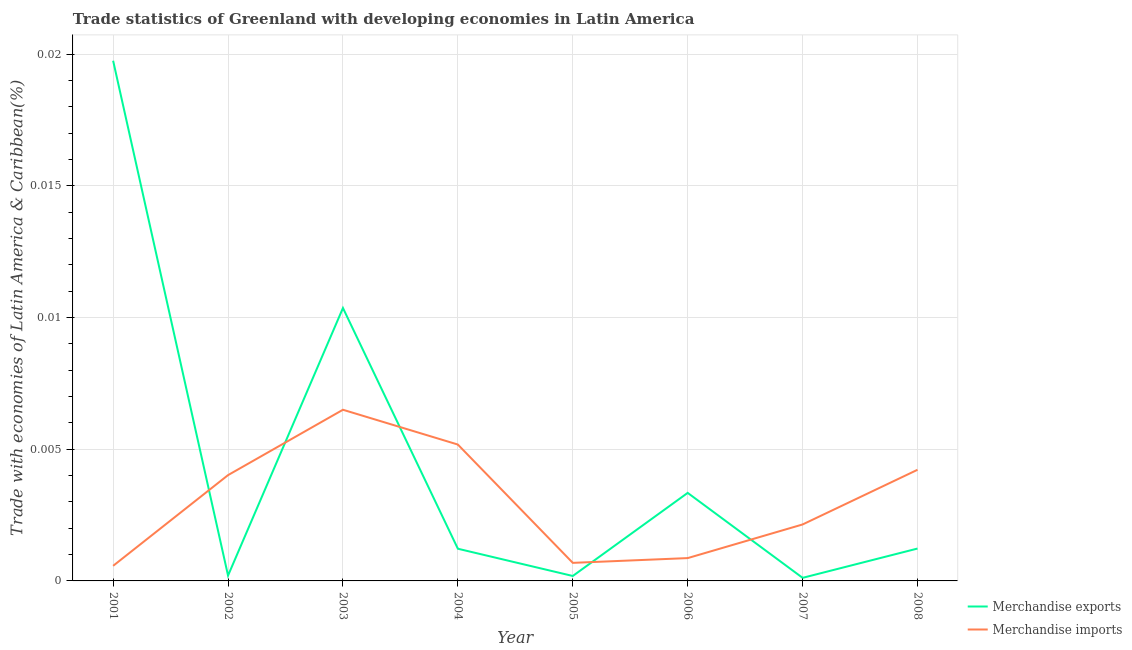How many different coloured lines are there?
Offer a terse response. 2. Is the number of lines equal to the number of legend labels?
Provide a short and direct response. Yes. What is the merchandise exports in 2006?
Provide a succinct answer. 0. Across all years, what is the maximum merchandise imports?
Provide a succinct answer. 0.01. Across all years, what is the minimum merchandise imports?
Offer a very short reply. 0. In which year was the merchandise exports maximum?
Your response must be concise. 2001. What is the total merchandise imports in the graph?
Give a very brief answer. 0.02. What is the difference between the merchandise exports in 2001 and that in 2006?
Offer a very short reply. 0.02. What is the difference between the merchandise exports in 2007 and the merchandise imports in 2006?
Ensure brevity in your answer.  -0. What is the average merchandise exports per year?
Your response must be concise. 0. In the year 2007, what is the difference between the merchandise exports and merchandise imports?
Offer a very short reply. -0. In how many years, is the merchandise exports greater than 0.006 %?
Your answer should be very brief. 2. What is the ratio of the merchandise exports in 2001 to that in 2003?
Ensure brevity in your answer.  1.91. Is the merchandise imports in 2002 less than that in 2005?
Make the answer very short. No. Is the difference between the merchandise exports in 2004 and 2007 greater than the difference between the merchandise imports in 2004 and 2007?
Offer a very short reply. No. What is the difference between the highest and the second highest merchandise imports?
Your answer should be very brief. 0. What is the difference between the highest and the lowest merchandise imports?
Make the answer very short. 0.01. Does the merchandise exports monotonically increase over the years?
Your answer should be very brief. No. Is the merchandise imports strictly greater than the merchandise exports over the years?
Ensure brevity in your answer.  No. How many lines are there?
Your answer should be very brief. 2. What is the difference between two consecutive major ticks on the Y-axis?
Provide a succinct answer. 0.01. Does the graph contain any zero values?
Offer a very short reply. No. Does the graph contain grids?
Your response must be concise. Yes. How many legend labels are there?
Your answer should be very brief. 2. How are the legend labels stacked?
Offer a very short reply. Vertical. What is the title of the graph?
Offer a terse response. Trade statistics of Greenland with developing economies in Latin America. Does "Education" appear as one of the legend labels in the graph?
Provide a short and direct response. No. What is the label or title of the X-axis?
Give a very brief answer. Year. What is the label or title of the Y-axis?
Your answer should be compact. Trade with economies of Latin America & Caribbean(%). What is the Trade with economies of Latin America & Caribbean(%) in Merchandise exports in 2001?
Provide a succinct answer. 0.02. What is the Trade with economies of Latin America & Caribbean(%) in Merchandise imports in 2001?
Keep it short and to the point. 0. What is the Trade with economies of Latin America & Caribbean(%) in Merchandise exports in 2002?
Your answer should be very brief. 0. What is the Trade with economies of Latin America & Caribbean(%) of Merchandise imports in 2002?
Keep it short and to the point. 0. What is the Trade with economies of Latin America & Caribbean(%) of Merchandise exports in 2003?
Your answer should be compact. 0.01. What is the Trade with economies of Latin America & Caribbean(%) in Merchandise imports in 2003?
Provide a succinct answer. 0.01. What is the Trade with economies of Latin America & Caribbean(%) of Merchandise exports in 2004?
Provide a succinct answer. 0. What is the Trade with economies of Latin America & Caribbean(%) in Merchandise imports in 2004?
Keep it short and to the point. 0.01. What is the Trade with economies of Latin America & Caribbean(%) in Merchandise exports in 2005?
Ensure brevity in your answer.  0. What is the Trade with economies of Latin America & Caribbean(%) in Merchandise imports in 2005?
Provide a short and direct response. 0. What is the Trade with economies of Latin America & Caribbean(%) in Merchandise exports in 2006?
Make the answer very short. 0. What is the Trade with economies of Latin America & Caribbean(%) of Merchandise imports in 2006?
Ensure brevity in your answer.  0. What is the Trade with economies of Latin America & Caribbean(%) of Merchandise exports in 2007?
Give a very brief answer. 0. What is the Trade with economies of Latin America & Caribbean(%) in Merchandise imports in 2007?
Keep it short and to the point. 0. What is the Trade with economies of Latin America & Caribbean(%) in Merchandise exports in 2008?
Offer a very short reply. 0. What is the Trade with economies of Latin America & Caribbean(%) in Merchandise imports in 2008?
Keep it short and to the point. 0. Across all years, what is the maximum Trade with economies of Latin America & Caribbean(%) in Merchandise exports?
Ensure brevity in your answer.  0.02. Across all years, what is the maximum Trade with economies of Latin America & Caribbean(%) in Merchandise imports?
Keep it short and to the point. 0.01. Across all years, what is the minimum Trade with economies of Latin America & Caribbean(%) in Merchandise exports?
Ensure brevity in your answer.  0. Across all years, what is the minimum Trade with economies of Latin America & Caribbean(%) in Merchandise imports?
Provide a succinct answer. 0. What is the total Trade with economies of Latin America & Caribbean(%) in Merchandise exports in the graph?
Your answer should be compact. 0.04. What is the total Trade with economies of Latin America & Caribbean(%) in Merchandise imports in the graph?
Provide a short and direct response. 0.02. What is the difference between the Trade with economies of Latin America & Caribbean(%) of Merchandise exports in 2001 and that in 2002?
Ensure brevity in your answer.  0.02. What is the difference between the Trade with economies of Latin America & Caribbean(%) in Merchandise imports in 2001 and that in 2002?
Your response must be concise. -0. What is the difference between the Trade with economies of Latin America & Caribbean(%) in Merchandise exports in 2001 and that in 2003?
Make the answer very short. 0.01. What is the difference between the Trade with economies of Latin America & Caribbean(%) of Merchandise imports in 2001 and that in 2003?
Your response must be concise. -0.01. What is the difference between the Trade with economies of Latin America & Caribbean(%) in Merchandise exports in 2001 and that in 2004?
Offer a very short reply. 0.02. What is the difference between the Trade with economies of Latin America & Caribbean(%) in Merchandise imports in 2001 and that in 2004?
Offer a very short reply. -0. What is the difference between the Trade with economies of Latin America & Caribbean(%) in Merchandise exports in 2001 and that in 2005?
Make the answer very short. 0.02. What is the difference between the Trade with economies of Latin America & Caribbean(%) in Merchandise imports in 2001 and that in 2005?
Ensure brevity in your answer.  -0. What is the difference between the Trade with economies of Latin America & Caribbean(%) in Merchandise exports in 2001 and that in 2006?
Provide a short and direct response. 0.02. What is the difference between the Trade with economies of Latin America & Caribbean(%) of Merchandise imports in 2001 and that in 2006?
Make the answer very short. -0. What is the difference between the Trade with economies of Latin America & Caribbean(%) in Merchandise exports in 2001 and that in 2007?
Keep it short and to the point. 0.02. What is the difference between the Trade with economies of Latin America & Caribbean(%) in Merchandise imports in 2001 and that in 2007?
Provide a short and direct response. -0. What is the difference between the Trade with economies of Latin America & Caribbean(%) of Merchandise exports in 2001 and that in 2008?
Provide a succinct answer. 0.02. What is the difference between the Trade with economies of Latin America & Caribbean(%) of Merchandise imports in 2001 and that in 2008?
Make the answer very short. -0. What is the difference between the Trade with economies of Latin America & Caribbean(%) of Merchandise exports in 2002 and that in 2003?
Offer a very short reply. -0.01. What is the difference between the Trade with economies of Latin America & Caribbean(%) in Merchandise imports in 2002 and that in 2003?
Your answer should be very brief. -0. What is the difference between the Trade with economies of Latin America & Caribbean(%) of Merchandise exports in 2002 and that in 2004?
Give a very brief answer. -0. What is the difference between the Trade with economies of Latin America & Caribbean(%) of Merchandise imports in 2002 and that in 2004?
Ensure brevity in your answer.  -0. What is the difference between the Trade with economies of Latin America & Caribbean(%) of Merchandise imports in 2002 and that in 2005?
Ensure brevity in your answer.  0. What is the difference between the Trade with economies of Latin America & Caribbean(%) in Merchandise exports in 2002 and that in 2006?
Give a very brief answer. -0. What is the difference between the Trade with economies of Latin America & Caribbean(%) in Merchandise imports in 2002 and that in 2006?
Your response must be concise. 0. What is the difference between the Trade with economies of Latin America & Caribbean(%) of Merchandise exports in 2002 and that in 2007?
Provide a short and direct response. 0. What is the difference between the Trade with economies of Latin America & Caribbean(%) in Merchandise imports in 2002 and that in 2007?
Your answer should be compact. 0. What is the difference between the Trade with economies of Latin America & Caribbean(%) of Merchandise exports in 2002 and that in 2008?
Your answer should be compact. -0. What is the difference between the Trade with economies of Latin America & Caribbean(%) of Merchandise imports in 2002 and that in 2008?
Your response must be concise. -0. What is the difference between the Trade with economies of Latin America & Caribbean(%) of Merchandise exports in 2003 and that in 2004?
Give a very brief answer. 0.01. What is the difference between the Trade with economies of Latin America & Caribbean(%) of Merchandise imports in 2003 and that in 2004?
Your answer should be very brief. 0. What is the difference between the Trade with economies of Latin America & Caribbean(%) in Merchandise exports in 2003 and that in 2005?
Your response must be concise. 0.01. What is the difference between the Trade with economies of Latin America & Caribbean(%) of Merchandise imports in 2003 and that in 2005?
Your answer should be compact. 0.01. What is the difference between the Trade with economies of Latin America & Caribbean(%) of Merchandise exports in 2003 and that in 2006?
Provide a succinct answer. 0.01. What is the difference between the Trade with economies of Latin America & Caribbean(%) in Merchandise imports in 2003 and that in 2006?
Your response must be concise. 0.01. What is the difference between the Trade with economies of Latin America & Caribbean(%) in Merchandise exports in 2003 and that in 2007?
Your answer should be compact. 0.01. What is the difference between the Trade with economies of Latin America & Caribbean(%) of Merchandise imports in 2003 and that in 2007?
Provide a short and direct response. 0. What is the difference between the Trade with economies of Latin America & Caribbean(%) in Merchandise exports in 2003 and that in 2008?
Ensure brevity in your answer.  0.01. What is the difference between the Trade with economies of Latin America & Caribbean(%) of Merchandise imports in 2003 and that in 2008?
Provide a succinct answer. 0. What is the difference between the Trade with economies of Latin America & Caribbean(%) of Merchandise imports in 2004 and that in 2005?
Give a very brief answer. 0. What is the difference between the Trade with economies of Latin America & Caribbean(%) in Merchandise exports in 2004 and that in 2006?
Keep it short and to the point. -0. What is the difference between the Trade with economies of Latin America & Caribbean(%) of Merchandise imports in 2004 and that in 2006?
Give a very brief answer. 0. What is the difference between the Trade with economies of Latin America & Caribbean(%) of Merchandise exports in 2004 and that in 2007?
Offer a very short reply. 0. What is the difference between the Trade with economies of Latin America & Caribbean(%) in Merchandise imports in 2004 and that in 2007?
Provide a short and direct response. 0. What is the difference between the Trade with economies of Latin America & Caribbean(%) in Merchandise exports in 2004 and that in 2008?
Offer a terse response. -0. What is the difference between the Trade with economies of Latin America & Caribbean(%) in Merchandise exports in 2005 and that in 2006?
Your answer should be compact. -0. What is the difference between the Trade with economies of Latin America & Caribbean(%) in Merchandise imports in 2005 and that in 2006?
Make the answer very short. -0. What is the difference between the Trade with economies of Latin America & Caribbean(%) in Merchandise exports in 2005 and that in 2007?
Make the answer very short. 0. What is the difference between the Trade with economies of Latin America & Caribbean(%) of Merchandise imports in 2005 and that in 2007?
Keep it short and to the point. -0. What is the difference between the Trade with economies of Latin America & Caribbean(%) in Merchandise exports in 2005 and that in 2008?
Give a very brief answer. -0. What is the difference between the Trade with economies of Latin America & Caribbean(%) in Merchandise imports in 2005 and that in 2008?
Your answer should be compact. -0. What is the difference between the Trade with economies of Latin America & Caribbean(%) of Merchandise exports in 2006 and that in 2007?
Offer a terse response. 0. What is the difference between the Trade with economies of Latin America & Caribbean(%) of Merchandise imports in 2006 and that in 2007?
Provide a succinct answer. -0. What is the difference between the Trade with economies of Latin America & Caribbean(%) in Merchandise exports in 2006 and that in 2008?
Offer a terse response. 0. What is the difference between the Trade with economies of Latin America & Caribbean(%) of Merchandise imports in 2006 and that in 2008?
Your answer should be very brief. -0. What is the difference between the Trade with economies of Latin America & Caribbean(%) in Merchandise exports in 2007 and that in 2008?
Your answer should be very brief. -0. What is the difference between the Trade with economies of Latin America & Caribbean(%) in Merchandise imports in 2007 and that in 2008?
Your answer should be compact. -0. What is the difference between the Trade with economies of Latin America & Caribbean(%) of Merchandise exports in 2001 and the Trade with economies of Latin America & Caribbean(%) of Merchandise imports in 2002?
Provide a succinct answer. 0.02. What is the difference between the Trade with economies of Latin America & Caribbean(%) in Merchandise exports in 2001 and the Trade with economies of Latin America & Caribbean(%) in Merchandise imports in 2003?
Keep it short and to the point. 0.01. What is the difference between the Trade with economies of Latin America & Caribbean(%) in Merchandise exports in 2001 and the Trade with economies of Latin America & Caribbean(%) in Merchandise imports in 2004?
Make the answer very short. 0.01. What is the difference between the Trade with economies of Latin America & Caribbean(%) in Merchandise exports in 2001 and the Trade with economies of Latin America & Caribbean(%) in Merchandise imports in 2005?
Offer a very short reply. 0.02. What is the difference between the Trade with economies of Latin America & Caribbean(%) of Merchandise exports in 2001 and the Trade with economies of Latin America & Caribbean(%) of Merchandise imports in 2006?
Your answer should be very brief. 0.02. What is the difference between the Trade with economies of Latin America & Caribbean(%) of Merchandise exports in 2001 and the Trade with economies of Latin America & Caribbean(%) of Merchandise imports in 2007?
Provide a short and direct response. 0.02. What is the difference between the Trade with economies of Latin America & Caribbean(%) in Merchandise exports in 2001 and the Trade with economies of Latin America & Caribbean(%) in Merchandise imports in 2008?
Your response must be concise. 0.02. What is the difference between the Trade with economies of Latin America & Caribbean(%) of Merchandise exports in 2002 and the Trade with economies of Latin America & Caribbean(%) of Merchandise imports in 2003?
Keep it short and to the point. -0.01. What is the difference between the Trade with economies of Latin America & Caribbean(%) of Merchandise exports in 2002 and the Trade with economies of Latin America & Caribbean(%) of Merchandise imports in 2004?
Offer a terse response. -0.01. What is the difference between the Trade with economies of Latin America & Caribbean(%) of Merchandise exports in 2002 and the Trade with economies of Latin America & Caribbean(%) of Merchandise imports in 2005?
Make the answer very short. -0. What is the difference between the Trade with economies of Latin America & Caribbean(%) in Merchandise exports in 2002 and the Trade with economies of Latin America & Caribbean(%) in Merchandise imports in 2006?
Your answer should be very brief. -0. What is the difference between the Trade with economies of Latin America & Caribbean(%) in Merchandise exports in 2002 and the Trade with economies of Latin America & Caribbean(%) in Merchandise imports in 2007?
Your answer should be very brief. -0. What is the difference between the Trade with economies of Latin America & Caribbean(%) in Merchandise exports in 2002 and the Trade with economies of Latin America & Caribbean(%) in Merchandise imports in 2008?
Your answer should be compact. -0. What is the difference between the Trade with economies of Latin America & Caribbean(%) of Merchandise exports in 2003 and the Trade with economies of Latin America & Caribbean(%) of Merchandise imports in 2004?
Keep it short and to the point. 0.01. What is the difference between the Trade with economies of Latin America & Caribbean(%) of Merchandise exports in 2003 and the Trade with economies of Latin America & Caribbean(%) of Merchandise imports in 2005?
Make the answer very short. 0.01. What is the difference between the Trade with economies of Latin America & Caribbean(%) in Merchandise exports in 2003 and the Trade with economies of Latin America & Caribbean(%) in Merchandise imports in 2006?
Provide a succinct answer. 0.01. What is the difference between the Trade with economies of Latin America & Caribbean(%) of Merchandise exports in 2003 and the Trade with economies of Latin America & Caribbean(%) of Merchandise imports in 2007?
Your response must be concise. 0.01. What is the difference between the Trade with economies of Latin America & Caribbean(%) of Merchandise exports in 2003 and the Trade with economies of Latin America & Caribbean(%) of Merchandise imports in 2008?
Offer a terse response. 0.01. What is the difference between the Trade with economies of Latin America & Caribbean(%) of Merchandise exports in 2004 and the Trade with economies of Latin America & Caribbean(%) of Merchandise imports in 2005?
Your response must be concise. 0. What is the difference between the Trade with economies of Latin America & Caribbean(%) in Merchandise exports in 2004 and the Trade with economies of Latin America & Caribbean(%) in Merchandise imports in 2006?
Keep it short and to the point. 0. What is the difference between the Trade with economies of Latin America & Caribbean(%) in Merchandise exports in 2004 and the Trade with economies of Latin America & Caribbean(%) in Merchandise imports in 2007?
Provide a short and direct response. -0. What is the difference between the Trade with economies of Latin America & Caribbean(%) of Merchandise exports in 2004 and the Trade with economies of Latin America & Caribbean(%) of Merchandise imports in 2008?
Offer a very short reply. -0. What is the difference between the Trade with economies of Latin America & Caribbean(%) of Merchandise exports in 2005 and the Trade with economies of Latin America & Caribbean(%) of Merchandise imports in 2006?
Provide a succinct answer. -0. What is the difference between the Trade with economies of Latin America & Caribbean(%) in Merchandise exports in 2005 and the Trade with economies of Latin America & Caribbean(%) in Merchandise imports in 2007?
Offer a very short reply. -0. What is the difference between the Trade with economies of Latin America & Caribbean(%) of Merchandise exports in 2005 and the Trade with economies of Latin America & Caribbean(%) of Merchandise imports in 2008?
Provide a succinct answer. -0. What is the difference between the Trade with economies of Latin America & Caribbean(%) of Merchandise exports in 2006 and the Trade with economies of Latin America & Caribbean(%) of Merchandise imports in 2007?
Make the answer very short. 0. What is the difference between the Trade with economies of Latin America & Caribbean(%) in Merchandise exports in 2006 and the Trade with economies of Latin America & Caribbean(%) in Merchandise imports in 2008?
Ensure brevity in your answer.  -0. What is the difference between the Trade with economies of Latin America & Caribbean(%) in Merchandise exports in 2007 and the Trade with economies of Latin America & Caribbean(%) in Merchandise imports in 2008?
Provide a succinct answer. -0. What is the average Trade with economies of Latin America & Caribbean(%) of Merchandise exports per year?
Keep it short and to the point. 0. What is the average Trade with economies of Latin America & Caribbean(%) in Merchandise imports per year?
Provide a short and direct response. 0. In the year 2001, what is the difference between the Trade with economies of Latin America & Caribbean(%) of Merchandise exports and Trade with economies of Latin America & Caribbean(%) of Merchandise imports?
Keep it short and to the point. 0.02. In the year 2002, what is the difference between the Trade with economies of Latin America & Caribbean(%) of Merchandise exports and Trade with economies of Latin America & Caribbean(%) of Merchandise imports?
Give a very brief answer. -0. In the year 2003, what is the difference between the Trade with economies of Latin America & Caribbean(%) of Merchandise exports and Trade with economies of Latin America & Caribbean(%) of Merchandise imports?
Offer a terse response. 0. In the year 2004, what is the difference between the Trade with economies of Latin America & Caribbean(%) in Merchandise exports and Trade with economies of Latin America & Caribbean(%) in Merchandise imports?
Give a very brief answer. -0. In the year 2005, what is the difference between the Trade with economies of Latin America & Caribbean(%) in Merchandise exports and Trade with economies of Latin America & Caribbean(%) in Merchandise imports?
Your answer should be very brief. -0. In the year 2006, what is the difference between the Trade with economies of Latin America & Caribbean(%) of Merchandise exports and Trade with economies of Latin America & Caribbean(%) of Merchandise imports?
Give a very brief answer. 0. In the year 2007, what is the difference between the Trade with economies of Latin America & Caribbean(%) in Merchandise exports and Trade with economies of Latin America & Caribbean(%) in Merchandise imports?
Your response must be concise. -0. In the year 2008, what is the difference between the Trade with economies of Latin America & Caribbean(%) in Merchandise exports and Trade with economies of Latin America & Caribbean(%) in Merchandise imports?
Provide a short and direct response. -0. What is the ratio of the Trade with economies of Latin America & Caribbean(%) in Merchandise exports in 2001 to that in 2002?
Offer a very short reply. 96.62. What is the ratio of the Trade with economies of Latin America & Caribbean(%) of Merchandise imports in 2001 to that in 2002?
Offer a very short reply. 0.14. What is the ratio of the Trade with economies of Latin America & Caribbean(%) of Merchandise exports in 2001 to that in 2003?
Provide a succinct answer. 1.91. What is the ratio of the Trade with economies of Latin America & Caribbean(%) in Merchandise imports in 2001 to that in 2003?
Keep it short and to the point. 0.09. What is the ratio of the Trade with economies of Latin America & Caribbean(%) of Merchandise exports in 2001 to that in 2004?
Your response must be concise. 16.16. What is the ratio of the Trade with economies of Latin America & Caribbean(%) in Merchandise imports in 2001 to that in 2004?
Your response must be concise. 0.11. What is the ratio of the Trade with economies of Latin America & Caribbean(%) of Merchandise exports in 2001 to that in 2005?
Keep it short and to the point. 105.34. What is the ratio of the Trade with economies of Latin America & Caribbean(%) in Merchandise imports in 2001 to that in 2005?
Keep it short and to the point. 0.84. What is the ratio of the Trade with economies of Latin America & Caribbean(%) in Merchandise exports in 2001 to that in 2006?
Your answer should be very brief. 5.91. What is the ratio of the Trade with economies of Latin America & Caribbean(%) of Merchandise imports in 2001 to that in 2006?
Give a very brief answer. 0.66. What is the ratio of the Trade with economies of Latin America & Caribbean(%) in Merchandise exports in 2001 to that in 2007?
Offer a very short reply. 168.95. What is the ratio of the Trade with economies of Latin America & Caribbean(%) of Merchandise imports in 2001 to that in 2007?
Your answer should be compact. 0.27. What is the ratio of the Trade with economies of Latin America & Caribbean(%) in Merchandise exports in 2001 to that in 2008?
Your answer should be very brief. 16.07. What is the ratio of the Trade with economies of Latin America & Caribbean(%) in Merchandise imports in 2001 to that in 2008?
Keep it short and to the point. 0.14. What is the ratio of the Trade with economies of Latin America & Caribbean(%) in Merchandise exports in 2002 to that in 2003?
Keep it short and to the point. 0.02. What is the ratio of the Trade with economies of Latin America & Caribbean(%) in Merchandise imports in 2002 to that in 2003?
Give a very brief answer. 0.62. What is the ratio of the Trade with economies of Latin America & Caribbean(%) of Merchandise exports in 2002 to that in 2004?
Offer a very short reply. 0.17. What is the ratio of the Trade with economies of Latin America & Caribbean(%) of Merchandise imports in 2002 to that in 2004?
Provide a short and direct response. 0.78. What is the ratio of the Trade with economies of Latin America & Caribbean(%) in Merchandise exports in 2002 to that in 2005?
Give a very brief answer. 1.09. What is the ratio of the Trade with economies of Latin America & Caribbean(%) in Merchandise imports in 2002 to that in 2005?
Your answer should be very brief. 5.86. What is the ratio of the Trade with economies of Latin America & Caribbean(%) of Merchandise exports in 2002 to that in 2006?
Give a very brief answer. 0.06. What is the ratio of the Trade with economies of Latin America & Caribbean(%) of Merchandise imports in 2002 to that in 2006?
Provide a succinct answer. 4.64. What is the ratio of the Trade with economies of Latin America & Caribbean(%) in Merchandise exports in 2002 to that in 2007?
Make the answer very short. 1.75. What is the ratio of the Trade with economies of Latin America & Caribbean(%) in Merchandise imports in 2002 to that in 2007?
Your answer should be compact. 1.87. What is the ratio of the Trade with economies of Latin America & Caribbean(%) in Merchandise exports in 2002 to that in 2008?
Make the answer very short. 0.17. What is the ratio of the Trade with economies of Latin America & Caribbean(%) of Merchandise exports in 2003 to that in 2004?
Give a very brief answer. 8.48. What is the ratio of the Trade with economies of Latin America & Caribbean(%) in Merchandise imports in 2003 to that in 2004?
Make the answer very short. 1.26. What is the ratio of the Trade with economies of Latin America & Caribbean(%) of Merchandise exports in 2003 to that in 2005?
Your answer should be compact. 55.27. What is the ratio of the Trade with economies of Latin America & Caribbean(%) of Merchandise imports in 2003 to that in 2005?
Keep it short and to the point. 9.48. What is the ratio of the Trade with economies of Latin America & Caribbean(%) in Merchandise exports in 2003 to that in 2006?
Make the answer very short. 3.1. What is the ratio of the Trade with economies of Latin America & Caribbean(%) in Merchandise imports in 2003 to that in 2006?
Keep it short and to the point. 7.5. What is the ratio of the Trade with economies of Latin America & Caribbean(%) in Merchandise exports in 2003 to that in 2007?
Keep it short and to the point. 88.64. What is the ratio of the Trade with economies of Latin America & Caribbean(%) of Merchandise imports in 2003 to that in 2007?
Keep it short and to the point. 3.03. What is the ratio of the Trade with economies of Latin America & Caribbean(%) in Merchandise exports in 2003 to that in 2008?
Your answer should be compact. 8.43. What is the ratio of the Trade with economies of Latin America & Caribbean(%) of Merchandise imports in 2003 to that in 2008?
Your response must be concise. 1.54. What is the ratio of the Trade with economies of Latin America & Caribbean(%) in Merchandise exports in 2004 to that in 2005?
Your answer should be very brief. 6.52. What is the ratio of the Trade with economies of Latin America & Caribbean(%) of Merchandise imports in 2004 to that in 2005?
Your answer should be very brief. 7.55. What is the ratio of the Trade with economies of Latin America & Caribbean(%) of Merchandise exports in 2004 to that in 2006?
Offer a very short reply. 0.37. What is the ratio of the Trade with economies of Latin America & Caribbean(%) in Merchandise imports in 2004 to that in 2006?
Provide a succinct answer. 5.97. What is the ratio of the Trade with economies of Latin America & Caribbean(%) in Merchandise exports in 2004 to that in 2007?
Keep it short and to the point. 10.45. What is the ratio of the Trade with economies of Latin America & Caribbean(%) in Merchandise imports in 2004 to that in 2007?
Keep it short and to the point. 2.42. What is the ratio of the Trade with economies of Latin America & Caribbean(%) of Merchandise exports in 2004 to that in 2008?
Your answer should be very brief. 0.99. What is the ratio of the Trade with economies of Latin America & Caribbean(%) in Merchandise imports in 2004 to that in 2008?
Your response must be concise. 1.23. What is the ratio of the Trade with economies of Latin America & Caribbean(%) of Merchandise exports in 2005 to that in 2006?
Keep it short and to the point. 0.06. What is the ratio of the Trade with economies of Latin America & Caribbean(%) of Merchandise imports in 2005 to that in 2006?
Your answer should be very brief. 0.79. What is the ratio of the Trade with economies of Latin America & Caribbean(%) of Merchandise exports in 2005 to that in 2007?
Offer a terse response. 1.6. What is the ratio of the Trade with economies of Latin America & Caribbean(%) of Merchandise imports in 2005 to that in 2007?
Make the answer very short. 0.32. What is the ratio of the Trade with economies of Latin America & Caribbean(%) of Merchandise exports in 2005 to that in 2008?
Your response must be concise. 0.15. What is the ratio of the Trade with economies of Latin America & Caribbean(%) in Merchandise imports in 2005 to that in 2008?
Your answer should be very brief. 0.16. What is the ratio of the Trade with economies of Latin America & Caribbean(%) in Merchandise exports in 2006 to that in 2007?
Provide a short and direct response. 28.6. What is the ratio of the Trade with economies of Latin America & Caribbean(%) in Merchandise imports in 2006 to that in 2007?
Offer a very short reply. 0.4. What is the ratio of the Trade with economies of Latin America & Caribbean(%) of Merchandise exports in 2006 to that in 2008?
Provide a succinct answer. 2.72. What is the ratio of the Trade with economies of Latin America & Caribbean(%) in Merchandise imports in 2006 to that in 2008?
Your answer should be very brief. 0.21. What is the ratio of the Trade with economies of Latin America & Caribbean(%) of Merchandise exports in 2007 to that in 2008?
Your response must be concise. 0.1. What is the ratio of the Trade with economies of Latin America & Caribbean(%) of Merchandise imports in 2007 to that in 2008?
Your response must be concise. 0.51. What is the difference between the highest and the second highest Trade with economies of Latin America & Caribbean(%) of Merchandise exports?
Offer a terse response. 0.01. What is the difference between the highest and the second highest Trade with economies of Latin America & Caribbean(%) in Merchandise imports?
Offer a very short reply. 0. What is the difference between the highest and the lowest Trade with economies of Latin America & Caribbean(%) in Merchandise exports?
Provide a succinct answer. 0.02. What is the difference between the highest and the lowest Trade with economies of Latin America & Caribbean(%) in Merchandise imports?
Make the answer very short. 0.01. 